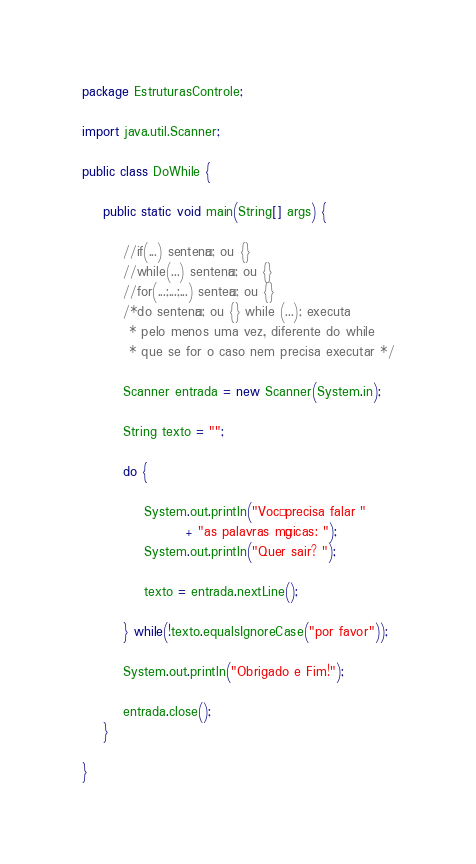<code> <loc_0><loc_0><loc_500><loc_500><_Java_>package EstruturasControle;

import java.util.Scanner;

public class DoWhile {

	public static void main(String[] args) {
		
		//if(...) sentença; ou {}
		//while(...) sentença; ou {}
		//for(...;...;...) senteça; ou {}
		/*do sentença; ou {} while (...); executa
		 * pelo menos uma vez, diferente do while
		 * que se for o caso nem precisa executar */
		
		Scanner entrada = new Scanner(System.in);
		
		String texto = "";
		
		do {
			
			System.out.println("Você precisa falar "
					+ "as palavras mágicas: ");
			System.out.println("Quer sair? ");
			
			texto = entrada.nextLine();
			
		} while(!texto.equalsIgnoreCase("por favor"));
		
		System.out.println("Obrigado e Fim!");
		
		entrada.close();
	}

}
</code> 